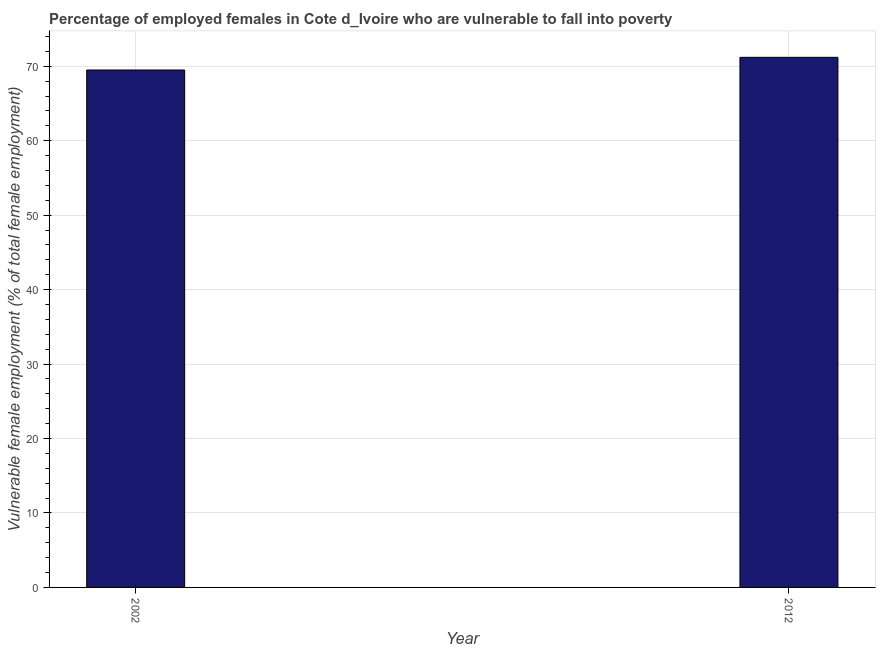What is the title of the graph?
Your answer should be very brief. Percentage of employed females in Cote d_Ivoire who are vulnerable to fall into poverty. What is the label or title of the Y-axis?
Provide a succinct answer. Vulnerable female employment (% of total female employment). What is the percentage of employed females who are vulnerable to fall into poverty in 2002?
Your response must be concise. 69.5. Across all years, what is the maximum percentage of employed females who are vulnerable to fall into poverty?
Give a very brief answer. 71.2. Across all years, what is the minimum percentage of employed females who are vulnerable to fall into poverty?
Your answer should be very brief. 69.5. In which year was the percentage of employed females who are vulnerable to fall into poverty maximum?
Make the answer very short. 2012. What is the sum of the percentage of employed females who are vulnerable to fall into poverty?
Make the answer very short. 140.7. What is the average percentage of employed females who are vulnerable to fall into poverty per year?
Offer a terse response. 70.35. What is the median percentage of employed females who are vulnerable to fall into poverty?
Give a very brief answer. 70.35. Do a majority of the years between 2002 and 2012 (inclusive) have percentage of employed females who are vulnerable to fall into poverty greater than 42 %?
Give a very brief answer. Yes. What is the ratio of the percentage of employed females who are vulnerable to fall into poverty in 2002 to that in 2012?
Offer a terse response. 0.98. What is the difference between two consecutive major ticks on the Y-axis?
Ensure brevity in your answer.  10. Are the values on the major ticks of Y-axis written in scientific E-notation?
Offer a terse response. No. What is the Vulnerable female employment (% of total female employment) in 2002?
Provide a short and direct response. 69.5. What is the Vulnerable female employment (% of total female employment) of 2012?
Offer a very short reply. 71.2. What is the difference between the Vulnerable female employment (% of total female employment) in 2002 and 2012?
Provide a succinct answer. -1.7. 